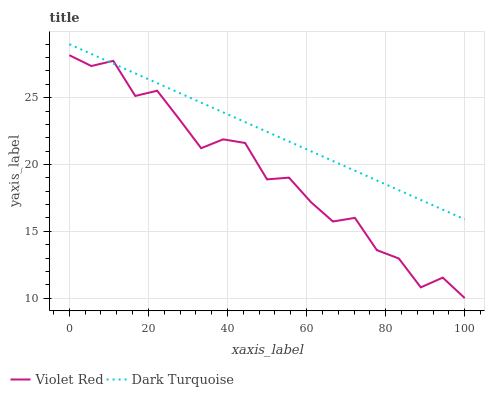Does Violet Red have the maximum area under the curve?
Answer yes or no. No. Is Violet Red the smoothest?
Answer yes or no. No. Does Violet Red have the highest value?
Answer yes or no. No. 